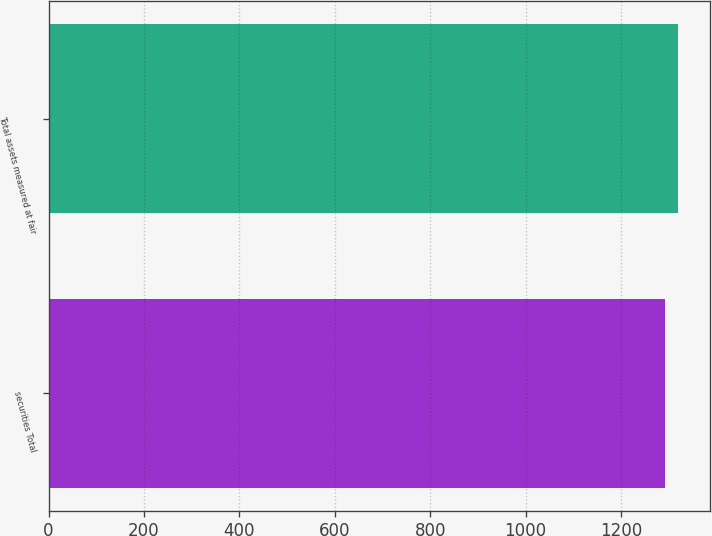<chart> <loc_0><loc_0><loc_500><loc_500><bar_chart><fcel>securities Total<fcel>Total assets measured at fair<nl><fcel>1292.2<fcel>1319.8<nl></chart> 